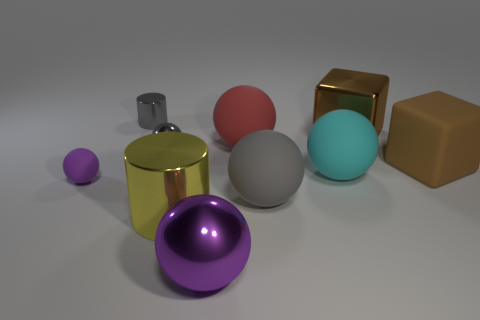Are there more small purple balls than things?
Give a very brief answer. No. What number of objects are small cyan rubber balls or large metallic things that are right of the big gray sphere?
Keep it short and to the point. 1. Is the cyan ball the same size as the brown shiny object?
Provide a short and direct response. Yes. Are there any cyan spheres left of the small gray cylinder?
Provide a succinct answer. No. How big is the sphere that is both on the left side of the yellow cylinder and in front of the cyan object?
Offer a very short reply. Small. How many things are cyan objects or small spheres?
Give a very brief answer. 3. There is a red sphere; is its size the same as the gray ball to the right of the purple metallic thing?
Provide a succinct answer. Yes. What is the size of the gray object that is on the right side of the purple ball that is on the right side of the small object that is in front of the large cyan matte sphere?
Offer a very short reply. Large. Are any large shiny things visible?
Make the answer very short. Yes. There is another block that is the same color as the rubber block; what is it made of?
Offer a very short reply. Metal. 